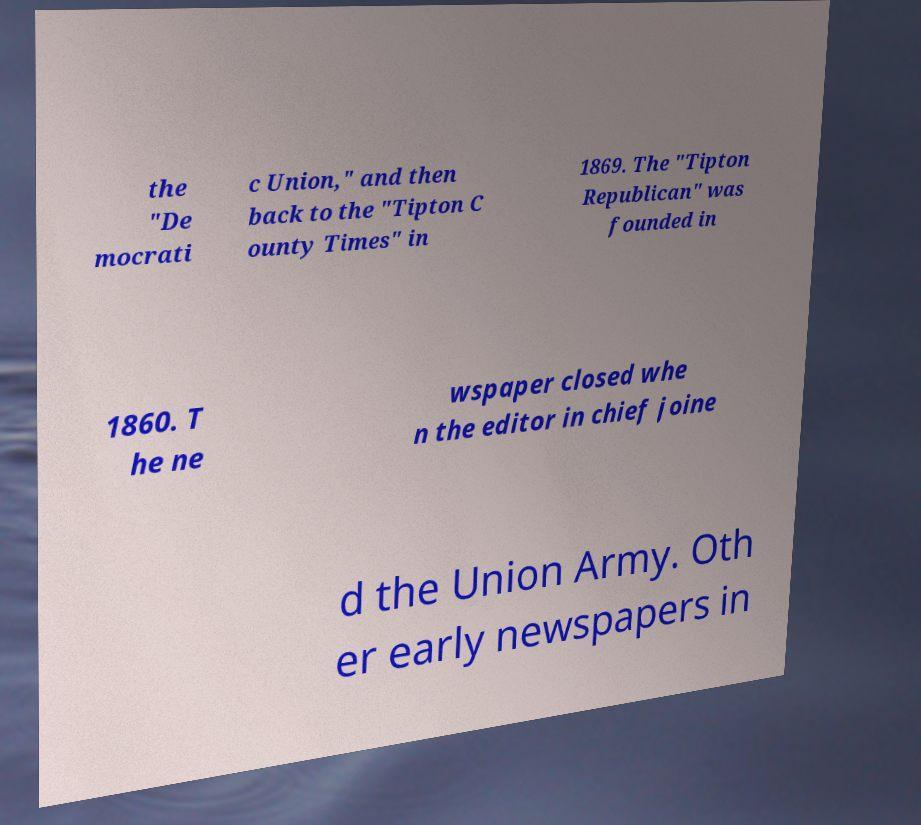I need the written content from this picture converted into text. Can you do that? the "De mocrati c Union," and then back to the "Tipton C ounty Times" in 1869. The "Tipton Republican" was founded in 1860. T he ne wspaper closed whe n the editor in chief joine d the Union Army. Oth er early newspapers in 